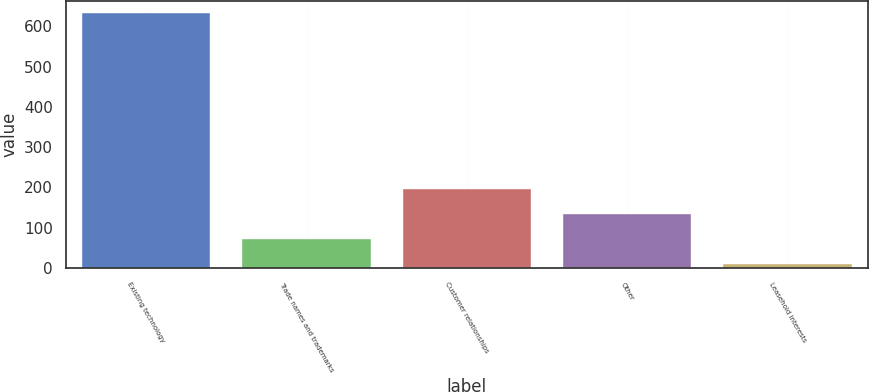<chart> <loc_0><loc_0><loc_500><loc_500><bar_chart><fcel>Existing technology<fcel>Trade names and trademarks<fcel>Customer relationships<fcel>Other<fcel>Leasehold interests<nl><fcel>632<fcel>72.2<fcel>196.6<fcel>134.4<fcel>10<nl></chart> 